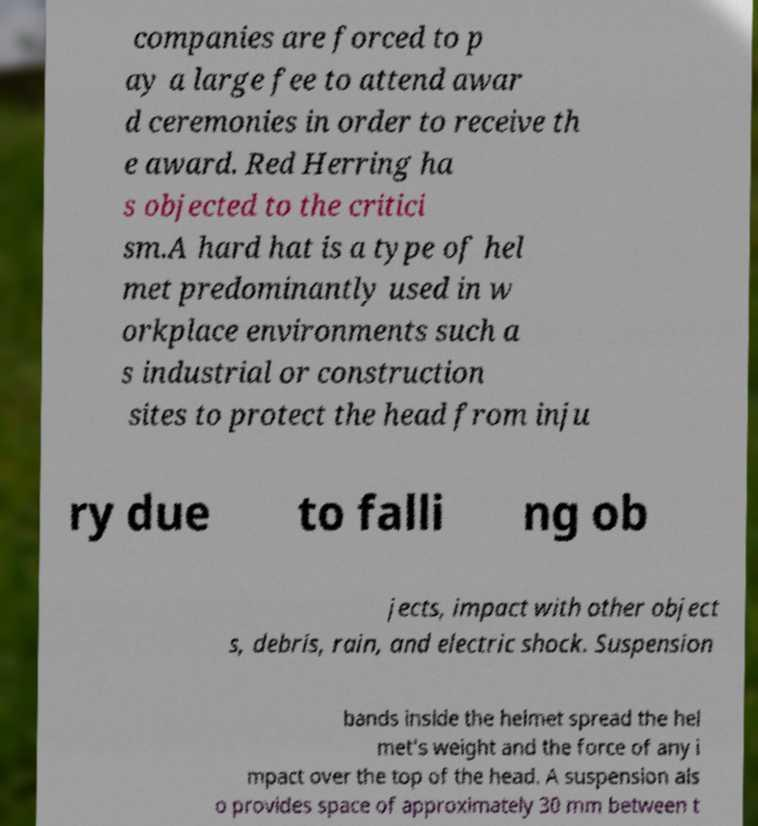What messages or text are displayed in this image? I need them in a readable, typed format. companies are forced to p ay a large fee to attend awar d ceremonies in order to receive th e award. Red Herring ha s objected to the critici sm.A hard hat is a type of hel met predominantly used in w orkplace environments such a s industrial or construction sites to protect the head from inju ry due to falli ng ob jects, impact with other object s, debris, rain, and electric shock. Suspension bands inside the helmet spread the hel met's weight and the force of any i mpact over the top of the head. A suspension als o provides space of approximately 30 mm between t 